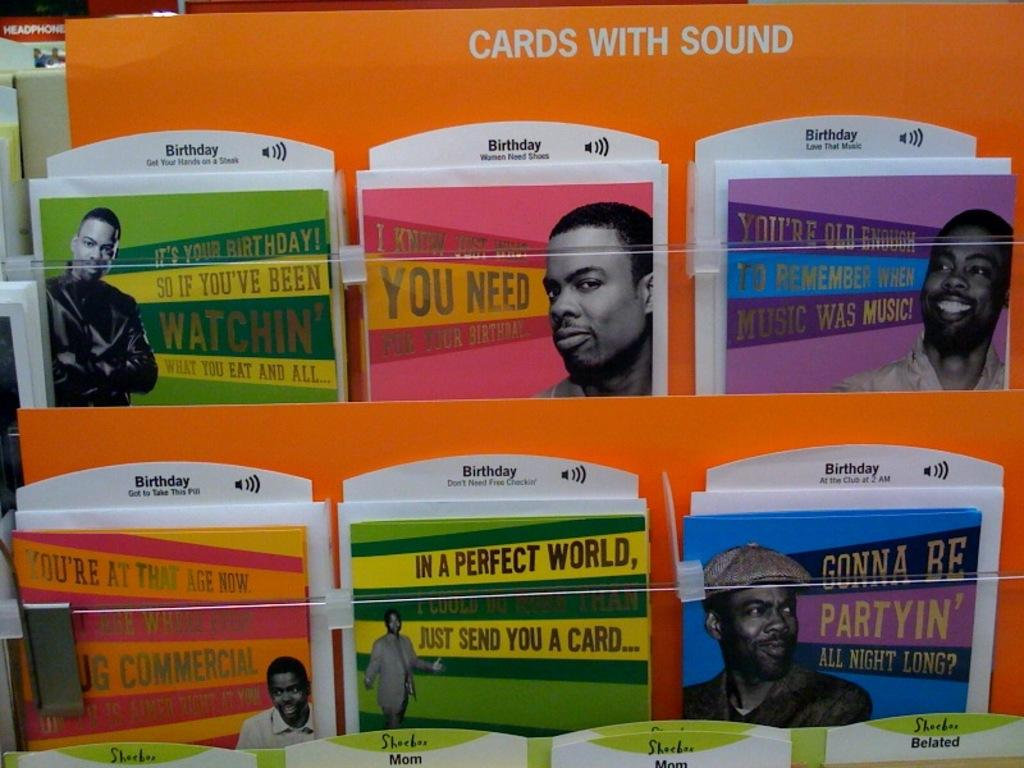What is the main subject of the image? The main subject of the image is a collection of cards arranged in rows. What can be seen on the cards? The cards have pictures of men on them. Are there any words or letters on the cards? Yes, there is text on the cards. What type of brush is being used to paint the bed in the image? There is no brush or bed present in the image; it only features cards with pictures of men and text. 